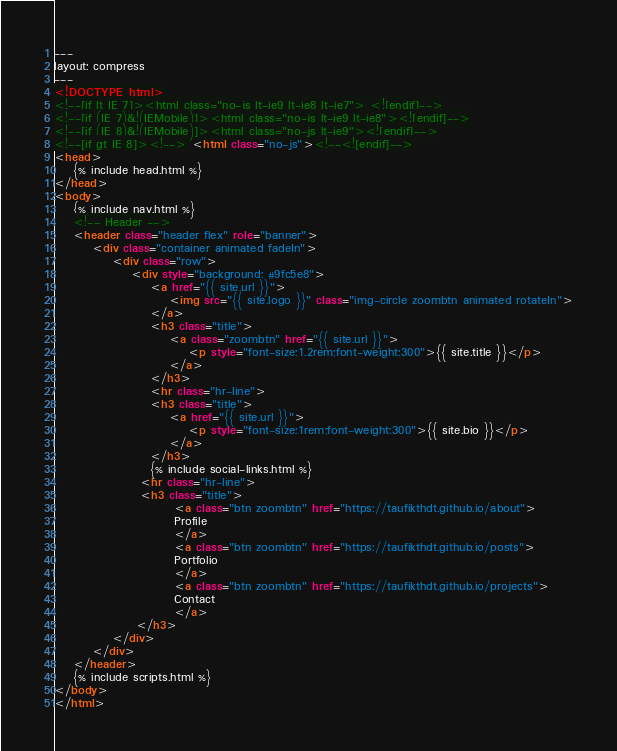<code> <loc_0><loc_0><loc_500><loc_500><_HTML_>---
layout: compress
---
<!DOCTYPE html>
<!--[if lt IE 7]><html class="no-js lt-ie9 lt-ie8 lt-ie7"> <![endif]-->
<!--[if (IE 7)&!(IEMobile)]><html class="no-js lt-ie9 lt-ie8"><![endif]-->
<!--[if (IE 8)&!(IEMobile)]><html class="no-js lt-ie9"><![endif]-->
<!--[if gt IE 8]><!--> <html class="no-js"><!--<![endif]-->
<head>
    {% include head.html %}
</head>
<body>
    {% include nav.html %}
    <!-- Header -->
    <header class="header flex" role="banner">
        <div class="container animated fadeIn">
            <div class="row">
                <div style="background: #9fc5e8">
                    <a href="{{ site.url }}">
                        <img src="{{ site.logo }}" class="img-circle zoombtn animated rotateIn">
                    </a>
                    <h3 class="title">
                        <a class="zoombtn" href="{{ site.url }}">
                        	<p style="font-size:1.2rem;font-weight:300">{{ site.title }}</p>
			            </a>
                    </h3>
                    <hr class="hr-line">
                    <h3 class="title">
                        <a href="{{ site.url }}">
                        	<p style="font-size:1rem;font-weight:300">{{ site.bio }}</p>
			            </a>
                    </h3>
                    {% include social-links.html %}
                  <hr class="hr-line">
                  <h3 class="title">
                         <a class="btn zoombtn" href="https://taufikthdt.github.io/about">
                         Profile
                         </a>
                         <a class="btn zoombtn" href="https://taufikthdt.github.io/posts">
                         Portfolio
                         </a>
                         <a class="btn zoombtn" href="https://taufikthdt.github.io/projects">
                         Contact
                         </a>
                 </h3>
            </div>
        </div>
    </header>
    {% include scripts.html %}
</body>
</html>
</code> 